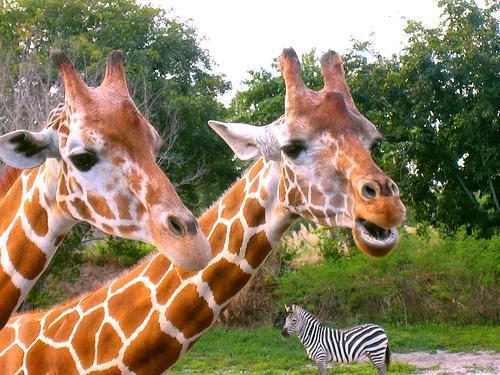How many zebras?
Give a very brief answer. 1. How many different animals are present here?
Give a very brief answer. 2. How many giraffes can be seen?
Give a very brief answer. 2. How many yellow cups are in the image?
Give a very brief answer. 0. 